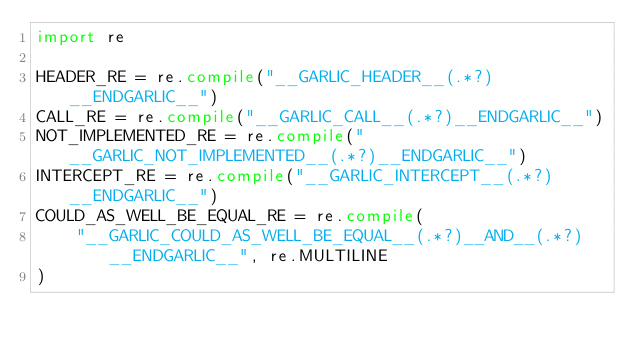<code> <loc_0><loc_0><loc_500><loc_500><_Python_>import re

HEADER_RE = re.compile("__GARLIC_HEADER__(.*?)__ENDGARLIC__")
CALL_RE = re.compile("__GARLIC_CALL__(.*?)__ENDGARLIC__")
NOT_IMPLEMENTED_RE = re.compile("__GARLIC_NOT_IMPLEMENTED__(.*?)__ENDGARLIC__")
INTERCEPT_RE = re.compile("__GARLIC_INTERCEPT__(.*?)__ENDGARLIC__")
COULD_AS_WELL_BE_EQUAL_RE = re.compile(
    "__GARLIC_COULD_AS_WELL_BE_EQUAL__(.*?)__AND__(.*?)__ENDGARLIC__", re.MULTILINE
)
</code> 